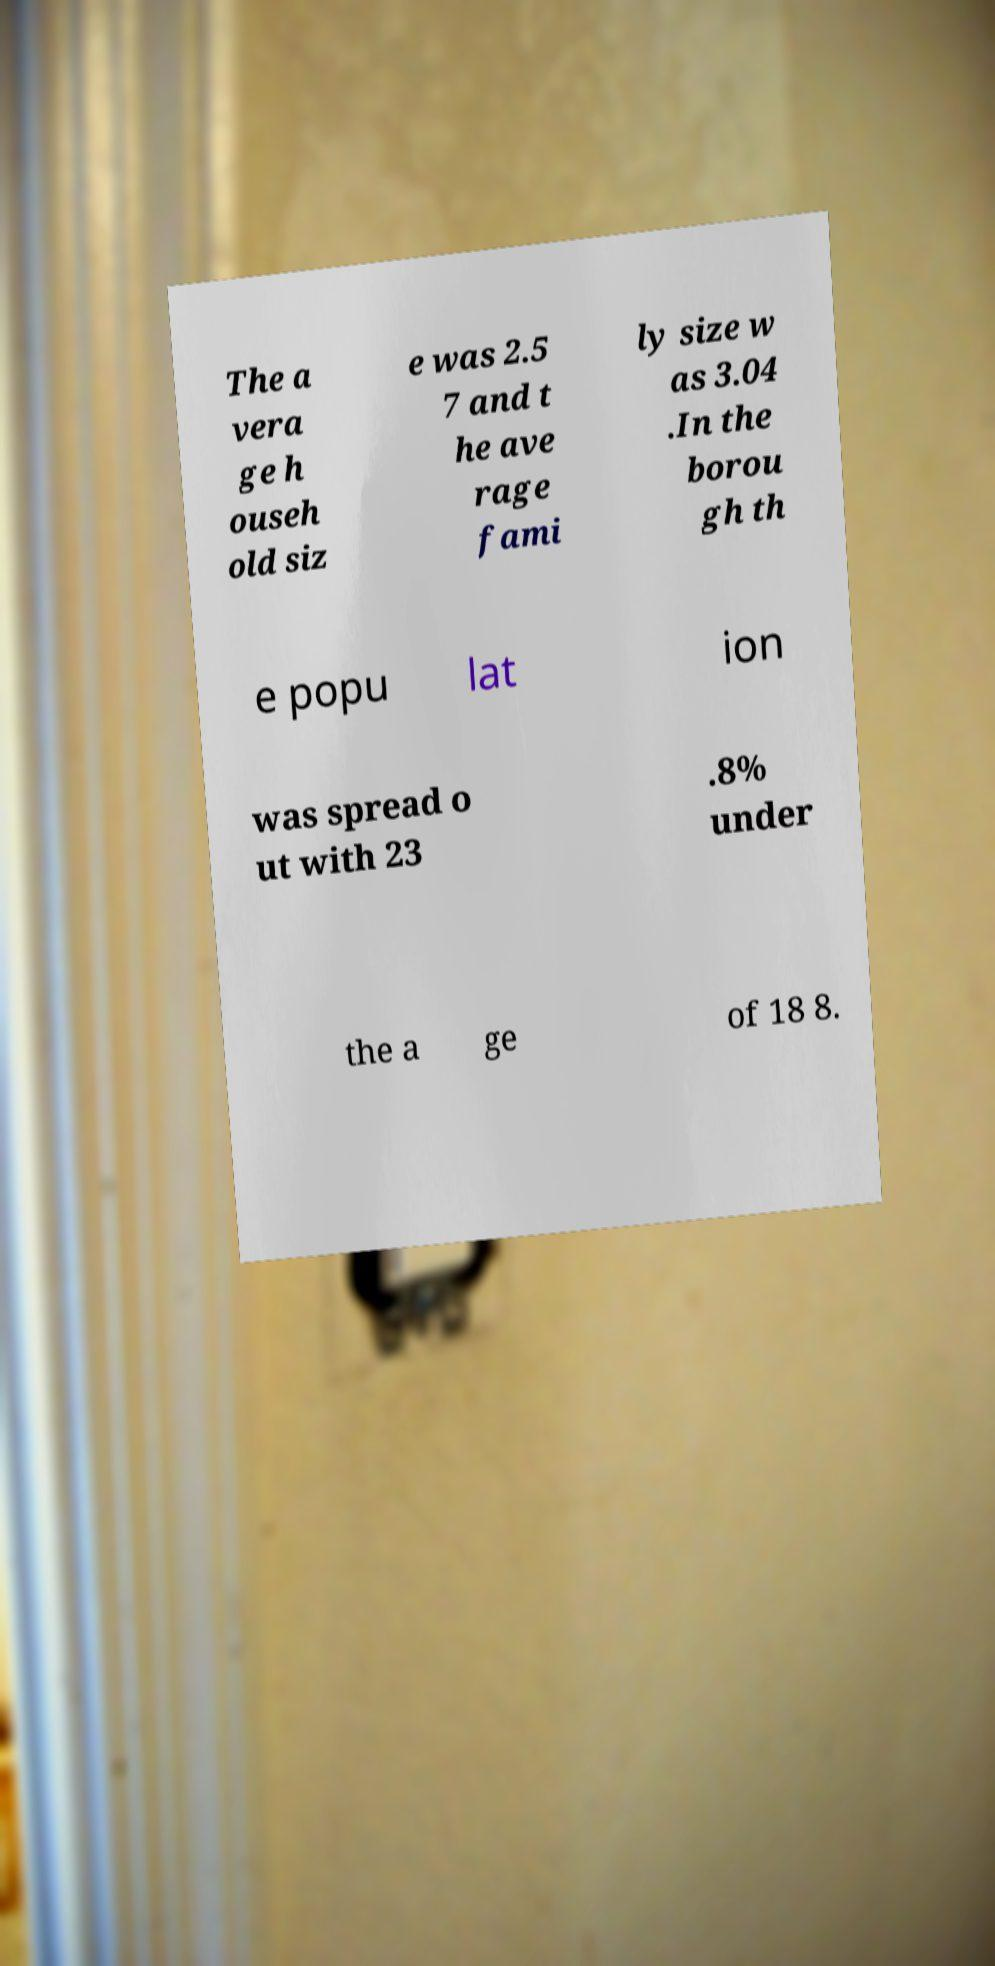Can you accurately transcribe the text from the provided image for me? The a vera ge h ouseh old siz e was 2.5 7 and t he ave rage fami ly size w as 3.04 .In the borou gh th e popu lat ion was spread o ut with 23 .8% under the a ge of 18 8. 